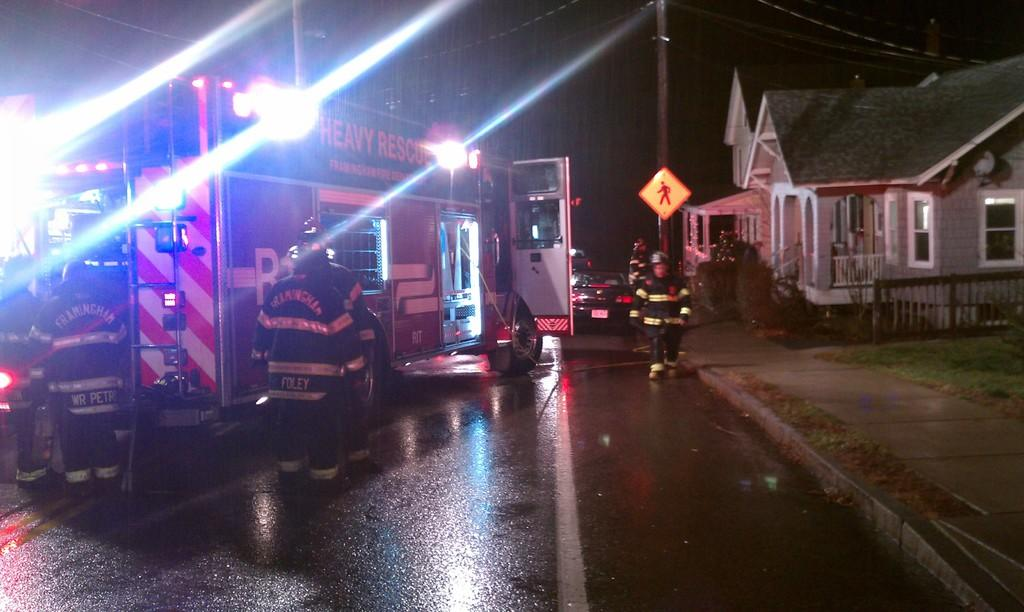What type of vehicle is in the image? There is a rescue truck in the image. What is the status of the rescue truck in the image? The rescue truck is parked. Are there any people associated with the rescue truck in the image? Yes, there are employees standing outside the rescue truck. What else can be seen on the road in the image? There is a car parked on the road in the image. What type of building is visible in the image? There is a house in the image. How many pizzas are being delivered by the rescue truck in the image? There are no pizzas mentioned or visible in the image. 